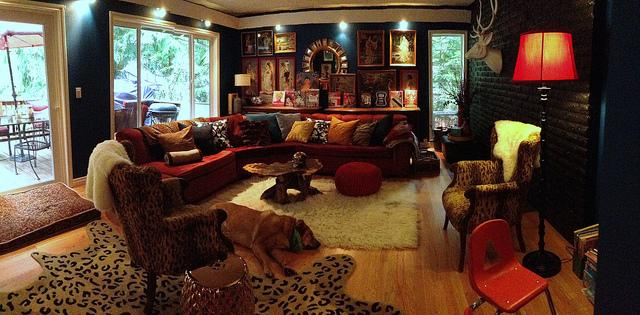What is hanging on the right side of the room? Please explain your reasoning. deer head. The deer head hangs. 